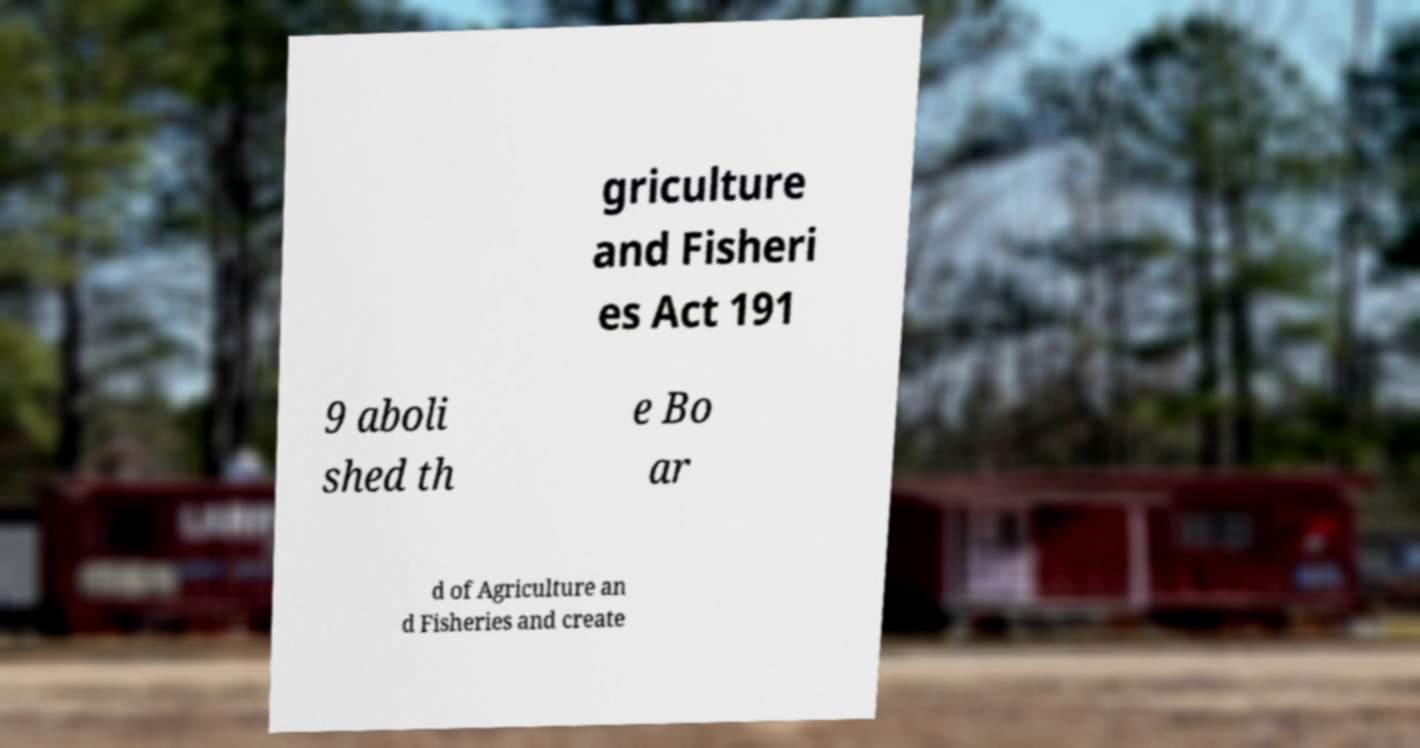Can you accurately transcribe the text from the provided image for me? griculture and Fisheri es Act 191 9 aboli shed th e Bo ar d of Agriculture an d Fisheries and create 